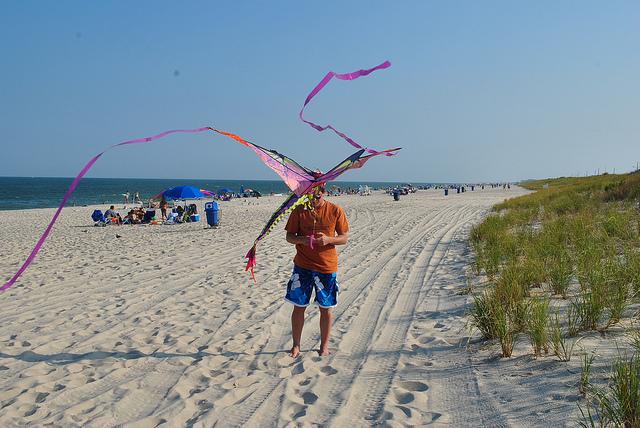Is the man's feet hot?
Answer briefly. Yes. Where is the blue umbrella?
Write a very short answer. On beach. What type of marks are in the sand?
Write a very short answer. Tire. 